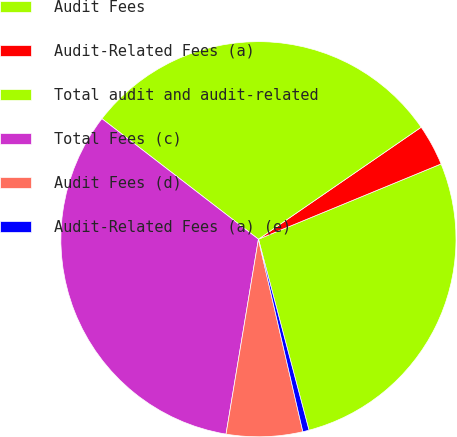Convert chart to OTSL. <chart><loc_0><loc_0><loc_500><loc_500><pie_chart><fcel>Audit Fees<fcel>Audit-Related Fees (a)<fcel>Total audit and audit-related<fcel>Total Fees (c)<fcel>Audit Fees (d)<fcel>Audit-Related Fees (a) (e)<nl><fcel>27.1%<fcel>3.37%<fcel>29.96%<fcel>32.82%<fcel>6.23%<fcel>0.51%<nl></chart> 